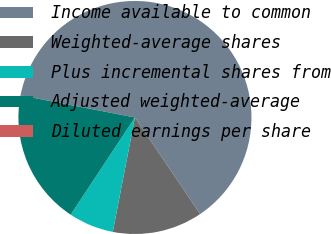Convert chart. <chart><loc_0><loc_0><loc_500><loc_500><pie_chart><fcel>Income available to common<fcel>Weighted-average shares<fcel>Plus incremental shares from<fcel>Adjusted weighted-average<fcel>Diluted earnings per share<nl><fcel>62.5%<fcel>12.5%<fcel>6.25%<fcel>18.75%<fcel>0.0%<nl></chart> 